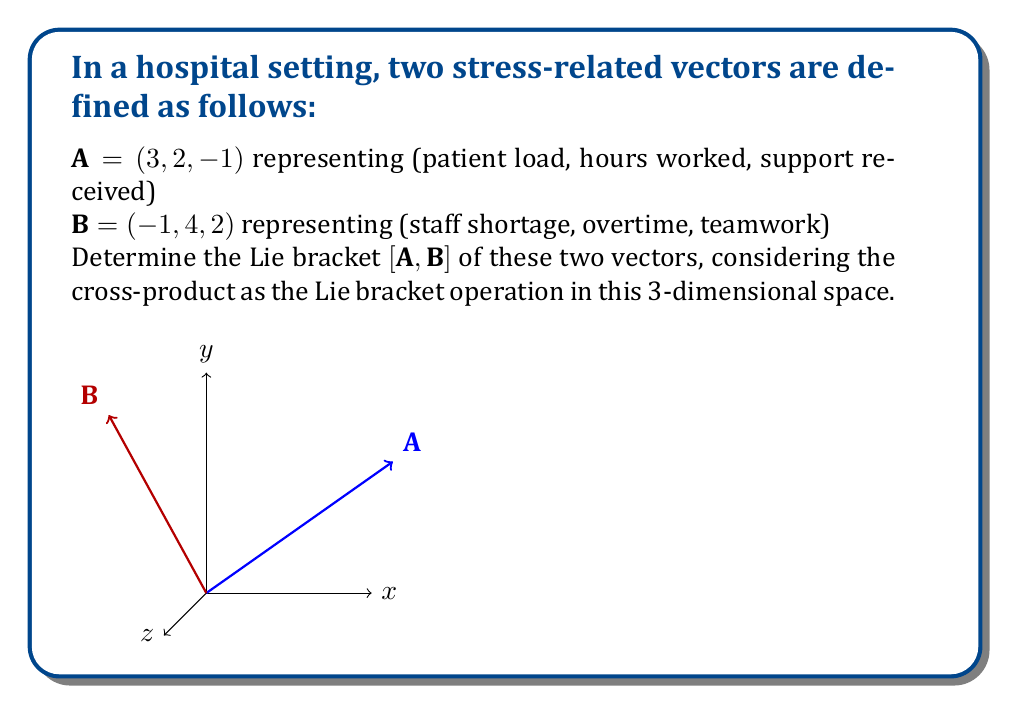Show me your answer to this math problem. To determine the Lie bracket $[\mathbf{A}, \mathbf{B}]$ using the cross-product operation, we follow these steps:

1) Recall the formula for the cross-product of two vectors $\mathbf{A} = (a_1, a_2, a_3)$ and $\mathbf{B} = (b_1, b_2, b_3)$:

   $$\mathbf{A} \times \mathbf{B} = (a_2b_3 - a_3b_2, a_3b_1 - a_1b_3, a_1b_2 - a_2b_1)$$

2) Identify the components of each vector:
   $\mathbf{A} = (3, 2, -1)$ and $\mathbf{B} = (-1, 4, 2)$

3) Calculate each component of the resultant vector:

   First component: $a_2b_3 - a_3b_2 = (2)(2) - (-1)(4) = 4 + 4 = 8$
   
   Second component: $a_3b_1 - a_1b_3 = (-1)(-1) - (3)(2) = 1 - 6 = -5$
   
   Third component: $a_1b_2 - a_2b_1 = (3)(4) - (2)(-1) = 12 + 2 = 14$

4) Combine the results into the final vector:

   $$[\mathbf{A}, \mathbf{B}] = \mathbf{A} \times \mathbf{B} = (8, -5, 14)$$

This result represents the interplay between the two stress-related factors in the hospital setting.
Answer: $(8, -5, 14)$ 